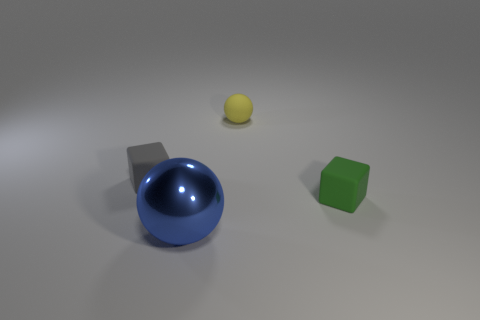Is there any other thing that is made of the same material as the blue thing?
Give a very brief answer. No. Is there anything else that has the same size as the blue sphere?
Make the answer very short. No. Is the number of blue metallic spheres in front of the large ball less than the number of small purple rubber cylinders?
Your answer should be compact. No. How many cubes are there?
Keep it short and to the point. 2. There is a tiny matte thing behind the tiny block to the left of the tiny green block; what is its shape?
Your response must be concise. Sphere. There is a yellow thing; what number of tiny matte objects are on the left side of it?
Your answer should be compact. 1. Are the blue ball and the cube left of the large blue metallic object made of the same material?
Provide a short and direct response. No. Are there any green cubes that have the same size as the gray matte cube?
Provide a short and direct response. Yes. Is the number of shiny balls that are in front of the small yellow matte sphere the same as the number of green rubber cubes?
Your answer should be very brief. Yes. The blue object is what size?
Provide a succinct answer. Large. 